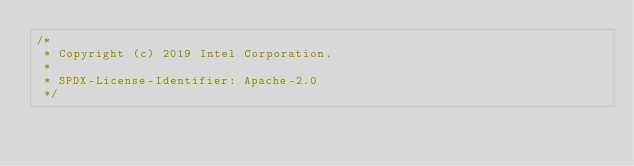Convert code to text. <code><loc_0><loc_0><loc_500><loc_500><_C_>/*
 * Copyright (c) 2019 Intel Corporation.
 *
 * SPDX-License-Identifier: Apache-2.0
 */
</code> 